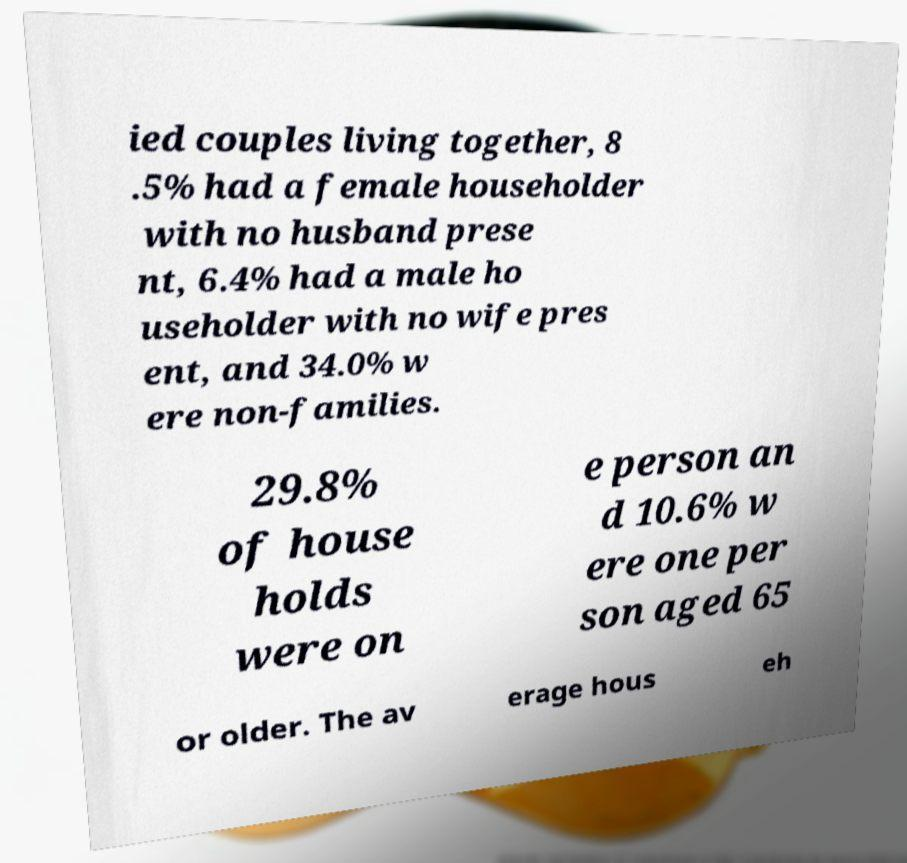For documentation purposes, I need the text within this image transcribed. Could you provide that? ied couples living together, 8 .5% had a female householder with no husband prese nt, 6.4% had a male ho useholder with no wife pres ent, and 34.0% w ere non-families. 29.8% of house holds were on e person an d 10.6% w ere one per son aged 65 or older. The av erage hous eh 